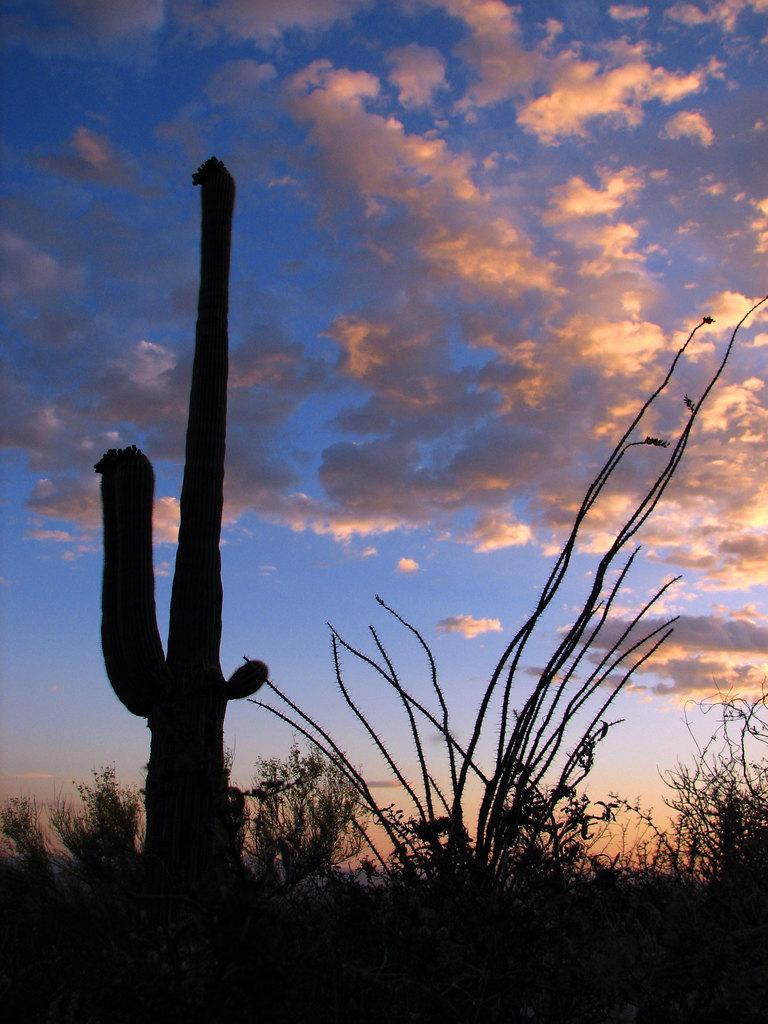What type of plant can be seen in the image? There is a cactus in the image. Are there any other plants visible besides the cactus? Yes, there are other plants in the image. What can be seen in the background of the image? Sky is visible in the background of the image. What is the condition of the sky in the image? Clouds are present in the sky. What type of business is being conducted at the desk in the image? There is no desk present in the image; it features a cactus and other plants. How many rails can be seen in the image? There are no rails present in the image. 